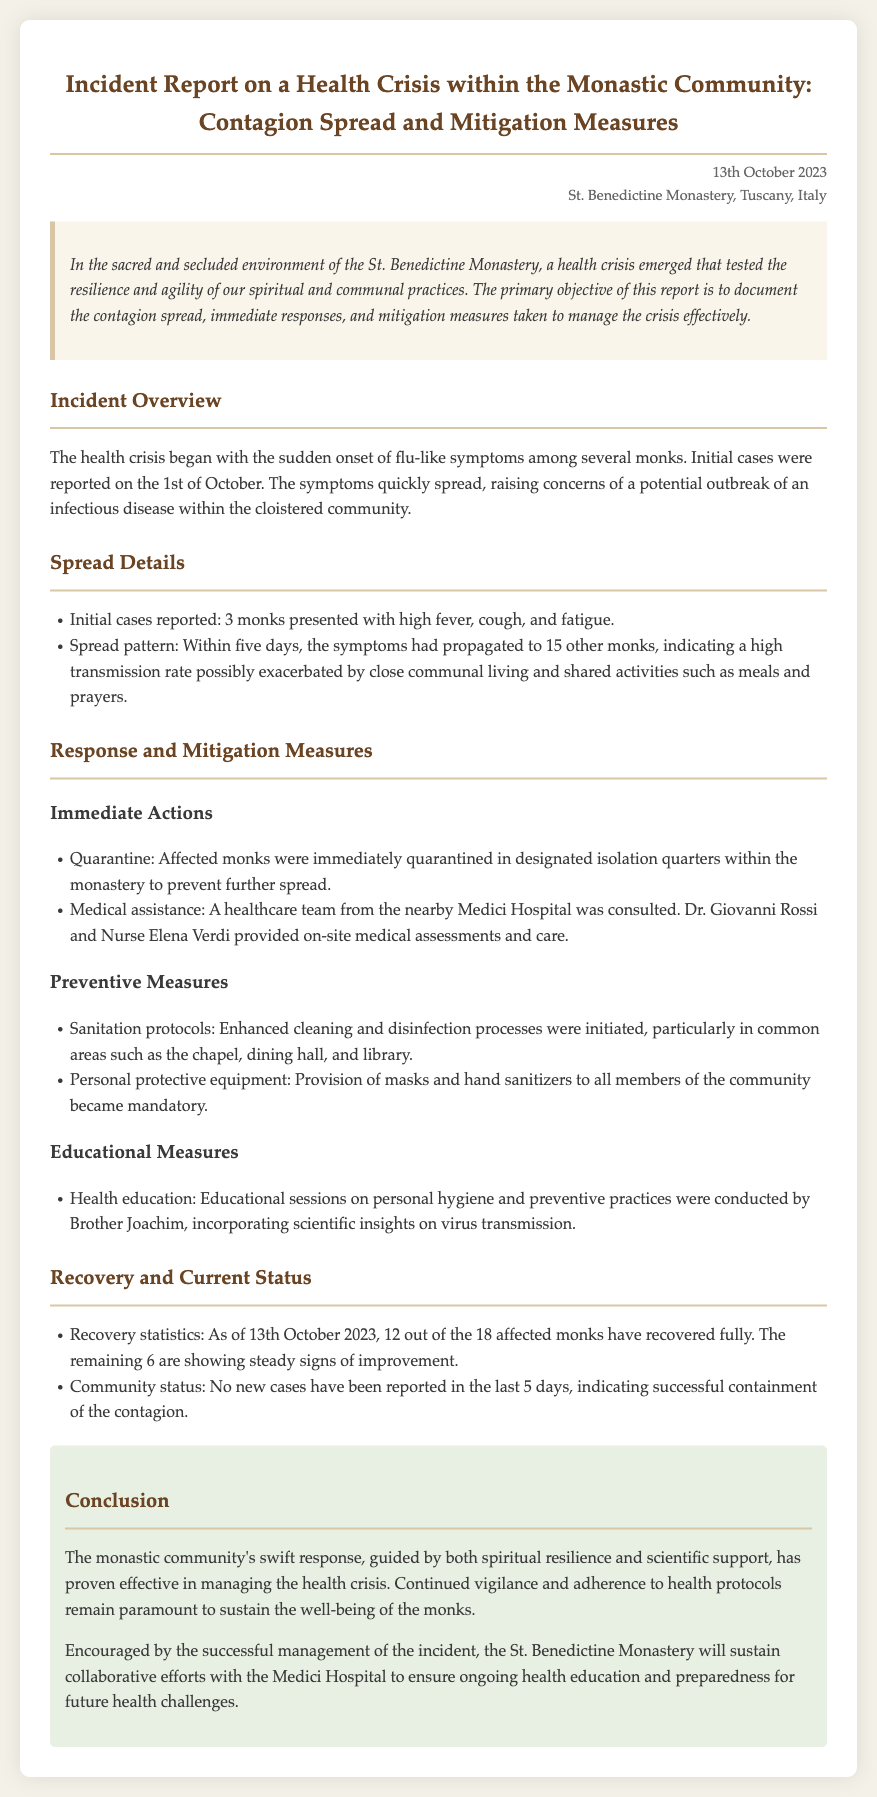What date did the incident report get published? The incident report was published on the date noted in the header section of the document.
Answer: 13th October 2023 What was the initial number of monks affected? The initial cases reported are specified in the "Spread Details" section of the document.
Answer: 3 monks Who provided on-site medical assessments? The names of the healthcare team members are mentioned under "Medical assistance" in the report.
Answer: Dr. Giovanni Rossi How many monks recovered fully by the report date? The report includes the recovery statistics relevant to the monks affected.
Answer: 12 What preventive measure was made mandatory for all members? The document outlines specific preventive actions taken during the health crisis.
Answer: Masks What is the name of the monastery where the incident occurred? The monastery's name is given in the title of the report.
Answer: St. Benedictine Monastery What role did Brother Joachim play in the response? The section on educational measures indicates his involvement during the health crisis.
Answer: Health education What was the symptom that initially presented among monks? The symptoms initially reported are specified in the incident overview of the document.
Answer: Flu-like symptoms 